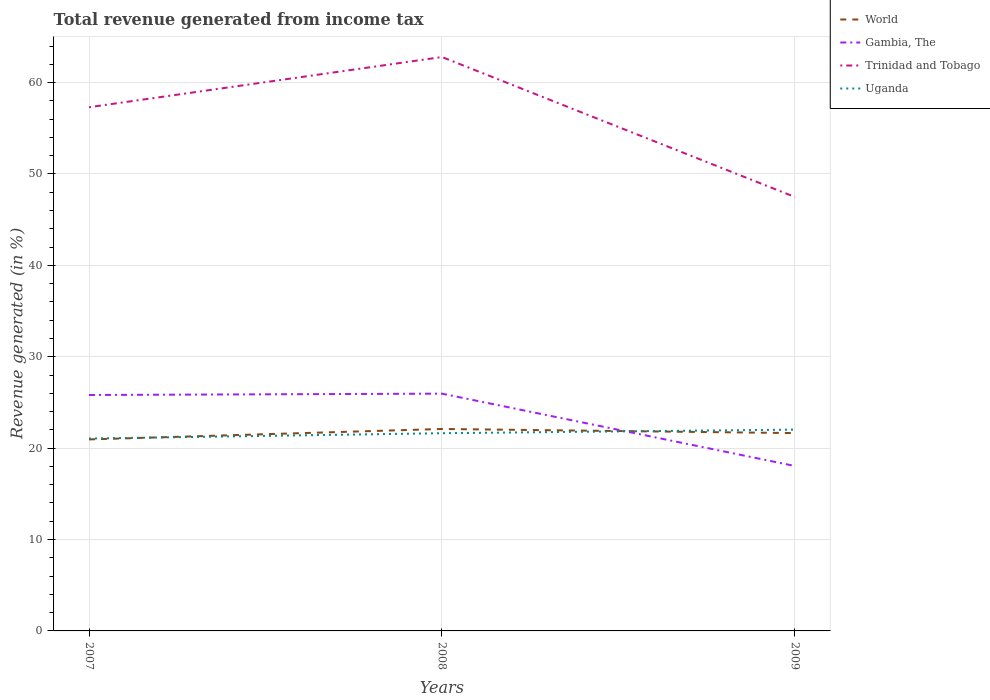Is the number of lines equal to the number of legend labels?
Keep it short and to the point. Yes. Across all years, what is the maximum total revenue generated in World?
Keep it short and to the point. 20.95. What is the total total revenue generated in Trinidad and Tobago in the graph?
Your answer should be compact. 15.32. What is the difference between the highest and the second highest total revenue generated in Uganda?
Ensure brevity in your answer.  0.98. Is the total revenue generated in World strictly greater than the total revenue generated in Gambia, The over the years?
Offer a terse response. No. How many lines are there?
Offer a very short reply. 4. How many years are there in the graph?
Your answer should be very brief. 3. Are the values on the major ticks of Y-axis written in scientific E-notation?
Ensure brevity in your answer.  No. Does the graph contain any zero values?
Your response must be concise. No. Does the graph contain grids?
Make the answer very short. Yes. How many legend labels are there?
Your answer should be compact. 4. What is the title of the graph?
Make the answer very short. Total revenue generated from income tax. What is the label or title of the Y-axis?
Make the answer very short. Revenue generated (in %). What is the Revenue generated (in %) in World in 2007?
Provide a short and direct response. 20.95. What is the Revenue generated (in %) in Gambia, The in 2007?
Make the answer very short. 25.82. What is the Revenue generated (in %) of Trinidad and Tobago in 2007?
Give a very brief answer. 57.3. What is the Revenue generated (in %) of Uganda in 2007?
Make the answer very short. 21.05. What is the Revenue generated (in %) of World in 2008?
Your answer should be compact. 22.1. What is the Revenue generated (in %) of Gambia, The in 2008?
Your response must be concise. 25.96. What is the Revenue generated (in %) in Trinidad and Tobago in 2008?
Offer a terse response. 62.79. What is the Revenue generated (in %) of Uganda in 2008?
Ensure brevity in your answer.  21.63. What is the Revenue generated (in %) of World in 2009?
Keep it short and to the point. 21.65. What is the Revenue generated (in %) of Gambia, The in 2009?
Provide a short and direct response. 18.04. What is the Revenue generated (in %) in Trinidad and Tobago in 2009?
Provide a short and direct response. 47.48. What is the Revenue generated (in %) in Uganda in 2009?
Offer a terse response. 22.03. Across all years, what is the maximum Revenue generated (in %) in World?
Make the answer very short. 22.1. Across all years, what is the maximum Revenue generated (in %) in Gambia, The?
Your answer should be very brief. 25.96. Across all years, what is the maximum Revenue generated (in %) of Trinidad and Tobago?
Ensure brevity in your answer.  62.79. Across all years, what is the maximum Revenue generated (in %) in Uganda?
Keep it short and to the point. 22.03. Across all years, what is the minimum Revenue generated (in %) in World?
Ensure brevity in your answer.  20.95. Across all years, what is the minimum Revenue generated (in %) of Gambia, The?
Provide a short and direct response. 18.04. Across all years, what is the minimum Revenue generated (in %) in Trinidad and Tobago?
Ensure brevity in your answer.  47.48. Across all years, what is the minimum Revenue generated (in %) in Uganda?
Provide a succinct answer. 21.05. What is the total Revenue generated (in %) in World in the graph?
Your answer should be compact. 64.7. What is the total Revenue generated (in %) in Gambia, The in the graph?
Your answer should be very brief. 69.82. What is the total Revenue generated (in %) of Trinidad and Tobago in the graph?
Provide a short and direct response. 167.57. What is the total Revenue generated (in %) of Uganda in the graph?
Your answer should be compact. 64.71. What is the difference between the Revenue generated (in %) in World in 2007 and that in 2008?
Keep it short and to the point. -1.14. What is the difference between the Revenue generated (in %) in Gambia, The in 2007 and that in 2008?
Your answer should be very brief. -0.15. What is the difference between the Revenue generated (in %) in Trinidad and Tobago in 2007 and that in 2008?
Provide a short and direct response. -5.49. What is the difference between the Revenue generated (in %) in Uganda in 2007 and that in 2008?
Your answer should be very brief. -0.58. What is the difference between the Revenue generated (in %) in World in 2007 and that in 2009?
Provide a succinct answer. -0.69. What is the difference between the Revenue generated (in %) of Gambia, The in 2007 and that in 2009?
Provide a short and direct response. 7.77. What is the difference between the Revenue generated (in %) in Trinidad and Tobago in 2007 and that in 2009?
Your answer should be compact. 9.82. What is the difference between the Revenue generated (in %) in Uganda in 2007 and that in 2009?
Give a very brief answer. -0.98. What is the difference between the Revenue generated (in %) in World in 2008 and that in 2009?
Your answer should be very brief. 0.45. What is the difference between the Revenue generated (in %) of Gambia, The in 2008 and that in 2009?
Your answer should be very brief. 7.92. What is the difference between the Revenue generated (in %) of Trinidad and Tobago in 2008 and that in 2009?
Offer a terse response. 15.32. What is the difference between the Revenue generated (in %) in Uganda in 2008 and that in 2009?
Offer a very short reply. -0.39. What is the difference between the Revenue generated (in %) of World in 2007 and the Revenue generated (in %) of Gambia, The in 2008?
Provide a short and direct response. -5.01. What is the difference between the Revenue generated (in %) of World in 2007 and the Revenue generated (in %) of Trinidad and Tobago in 2008?
Make the answer very short. -41.84. What is the difference between the Revenue generated (in %) of World in 2007 and the Revenue generated (in %) of Uganda in 2008?
Provide a short and direct response. -0.68. What is the difference between the Revenue generated (in %) of Gambia, The in 2007 and the Revenue generated (in %) of Trinidad and Tobago in 2008?
Offer a terse response. -36.98. What is the difference between the Revenue generated (in %) of Gambia, The in 2007 and the Revenue generated (in %) of Uganda in 2008?
Provide a succinct answer. 4.18. What is the difference between the Revenue generated (in %) of Trinidad and Tobago in 2007 and the Revenue generated (in %) of Uganda in 2008?
Your response must be concise. 35.67. What is the difference between the Revenue generated (in %) in World in 2007 and the Revenue generated (in %) in Gambia, The in 2009?
Provide a short and direct response. 2.91. What is the difference between the Revenue generated (in %) in World in 2007 and the Revenue generated (in %) in Trinidad and Tobago in 2009?
Make the answer very short. -26.52. What is the difference between the Revenue generated (in %) of World in 2007 and the Revenue generated (in %) of Uganda in 2009?
Your response must be concise. -1.07. What is the difference between the Revenue generated (in %) in Gambia, The in 2007 and the Revenue generated (in %) in Trinidad and Tobago in 2009?
Ensure brevity in your answer.  -21.66. What is the difference between the Revenue generated (in %) in Gambia, The in 2007 and the Revenue generated (in %) in Uganda in 2009?
Offer a very short reply. 3.79. What is the difference between the Revenue generated (in %) of Trinidad and Tobago in 2007 and the Revenue generated (in %) of Uganda in 2009?
Give a very brief answer. 35.27. What is the difference between the Revenue generated (in %) of World in 2008 and the Revenue generated (in %) of Gambia, The in 2009?
Ensure brevity in your answer.  4.05. What is the difference between the Revenue generated (in %) in World in 2008 and the Revenue generated (in %) in Trinidad and Tobago in 2009?
Keep it short and to the point. -25.38. What is the difference between the Revenue generated (in %) of World in 2008 and the Revenue generated (in %) of Uganda in 2009?
Your answer should be very brief. 0.07. What is the difference between the Revenue generated (in %) in Gambia, The in 2008 and the Revenue generated (in %) in Trinidad and Tobago in 2009?
Provide a succinct answer. -21.52. What is the difference between the Revenue generated (in %) of Gambia, The in 2008 and the Revenue generated (in %) of Uganda in 2009?
Provide a succinct answer. 3.94. What is the difference between the Revenue generated (in %) of Trinidad and Tobago in 2008 and the Revenue generated (in %) of Uganda in 2009?
Offer a very short reply. 40.77. What is the average Revenue generated (in %) in World per year?
Your answer should be very brief. 21.57. What is the average Revenue generated (in %) of Gambia, The per year?
Keep it short and to the point. 23.27. What is the average Revenue generated (in %) of Trinidad and Tobago per year?
Provide a succinct answer. 55.86. What is the average Revenue generated (in %) of Uganda per year?
Provide a succinct answer. 21.57. In the year 2007, what is the difference between the Revenue generated (in %) in World and Revenue generated (in %) in Gambia, The?
Provide a succinct answer. -4.86. In the year 2007, what is the difference between the Revenue generated (in %) of World and Revenue generated (in %) of Trinidad and Tobago?
Your answer should be very brief. -36.35. In the year 2007, what is the difference between the Revenue generated (in %) in World and Revenue generated (in %) in Uganda?
Provide a succinct answer. -0.1. In the year 2007, what is the difference between the Revenue generated (in %) of Gambia, The and Revenue generated (in %) of Trinidad and Tobago?
Your answer should be compact. -31.48. In the year 2007, what is the difference between the Revenue generated (in %) of Gambia, The and Revenue generated (in %) of Uganda?
Provide a short and direct response. 4.77. In the year 2007, what is the difference between the Revenue generated (in %) in Trinidad and Tobago and Revenue generated (in %) in Uganda?
Your response must be concise. 36.25. In the year 2008, what is the difference between the Revenue generated (in %) of World and Revenue generated (in %) of Gambia, The?
Give a very brief answer. -3.86. In the year 2008, what is the difference between the Revenue generated (in %) in World and Revenue generated (in %) in Trinidad and Tobago?
Offer a terse response. -40.7. In the year 2008, what is the difference between the Revenue generated (in %) in World and Revenue generated (in %) in Uganda?
Your answer should be compact. 0.46. In the year 2008, what is the difference between the Revenue generated (in %) in Gambia, The and Revenue generated (in %) in Trinidad and Tobago?
Your response must be concise. -36.83. In the year 2008, what is the difference between the Revenue generated (in %) in Gambia, The and Revenue generated (in %) in Uganda?
Keep it short and to the point. 4.33. In the year 2008, what is the difference between the Revenue generated (in %) of Trinidad and Tobago and Revenue generated (in %) of Uganda?
Provide a short and direct response. 41.16. In the year 2009, what is the difference between the Revenue generated (in %) of World and Revenue generated (in %) of Gambia, The?
Make the answer very short. 3.6. In the year 2009, what is the difference between the Revenue generated (in %) of World and Revenue generated (in %) of Trinidad and Tobago?
Your answer should be very brief. -25.83. In the year 2009, what is the difference between the Revenue generated (in %) of World and Revenue generated (in %) of Uganda?
Your answer should be very brief. -0.38. In the year 2009, what is the difference between the Revenue generated (in %) in Gambia, The and Revenue generated (in %) in Trinidad and Tobago?
Your answer should be very brief. -29.43. In the year 2009, what is the difference between the Revenue generated (in %) in Gambia, The and Revenue generated (in %) in Uganda?
Your answer should be compact. -3.98. In the year 2009, what is the difference between the Revenue generated (in %) of Trinidad and Tobago and Revenue generated (in %) of Uganda?
Make the answer very short. 25.45. What is the ratio of the Revenue generated (in %) in World in 2007 to that in 2008?
Provide a succinct answer. 0.95. What is the ratio of the Revenue generated (in %) of Gambia, The in 2007 to that in 2008?
Make the answer very short. 0.99. What is the ratio of the Revenue generated (in %) of Trinidad and Tobago in 2007 to that in 2008?
Your response must be concise. 0.91. What is the ratio of the Revenue generated (in %) of World in 2007 to that in 2009?
Offer a terse response. 0.97. What is the ratio of the Revenue generated (in %) in Gambia, The in 2007 to that in 2009?
Make the answer very short. 1.43. What is the ratio of the Revenue generated (in %) in Trinidad and Tobago in 2007 to that in 2009?
Keep it short and to the point. 1.21. What is the ratio of the Revenue generated (in %) in Uganda in 2007 to that in 2009?
Your answer should be very brief. 0.96. What is the ratio of the Revenue generated (in %) in World in 2008 to that in 2009?
Provide a succinct answer. 1.02. What is the ratio of the Revenue generated (in %) in Gambia, The in 2008 to that in 2009?
Keep it short and to the point. 1.44. What is the ratio of the Revenue generated (in %) in Trinidad and Tobago in 2008 to that in 2009?
Give a very brief answer. 1.32. What is the ratio of the Revenue generated (in %) of Uganda in 2008 to that in 2009?
Keep it short and to the point. 0.98. What is the difference between the highest and the second highest Revenue generated (in %) in World?
Ensure brevity in your answer.  0.45. What is the difference between the highest and the second highest Revenue generated (in %) in Gambia, The?
Ensure brevity in your answer.  0.15. What is the difference between the highest and the second highest Revenue generated (in %) in Trinidad and Tobago?
Your answer should be very brief. 5.49. What is the difference between the highest and the second highest Revenue generated (in %) of Uganda?
Provide a short and direct response. 0.39. What is the difference between the highest and the lowest Revenue generated (in %) in World?
Make the answer very short. 1.14. What is the difference between the highest and the lowest Revenue generated (in %) of Gambia, The?
Provide a succinct answer. 7.92. What is the difference between the highest and the lowest Revenue generated (in %) in Trinidad and Tobago?
Offer a very short reply. 15.32. What is the difference between the highest and the lowest Revenue generated (in %) of Uganda?
Provide a succinct answer. 0.98. 